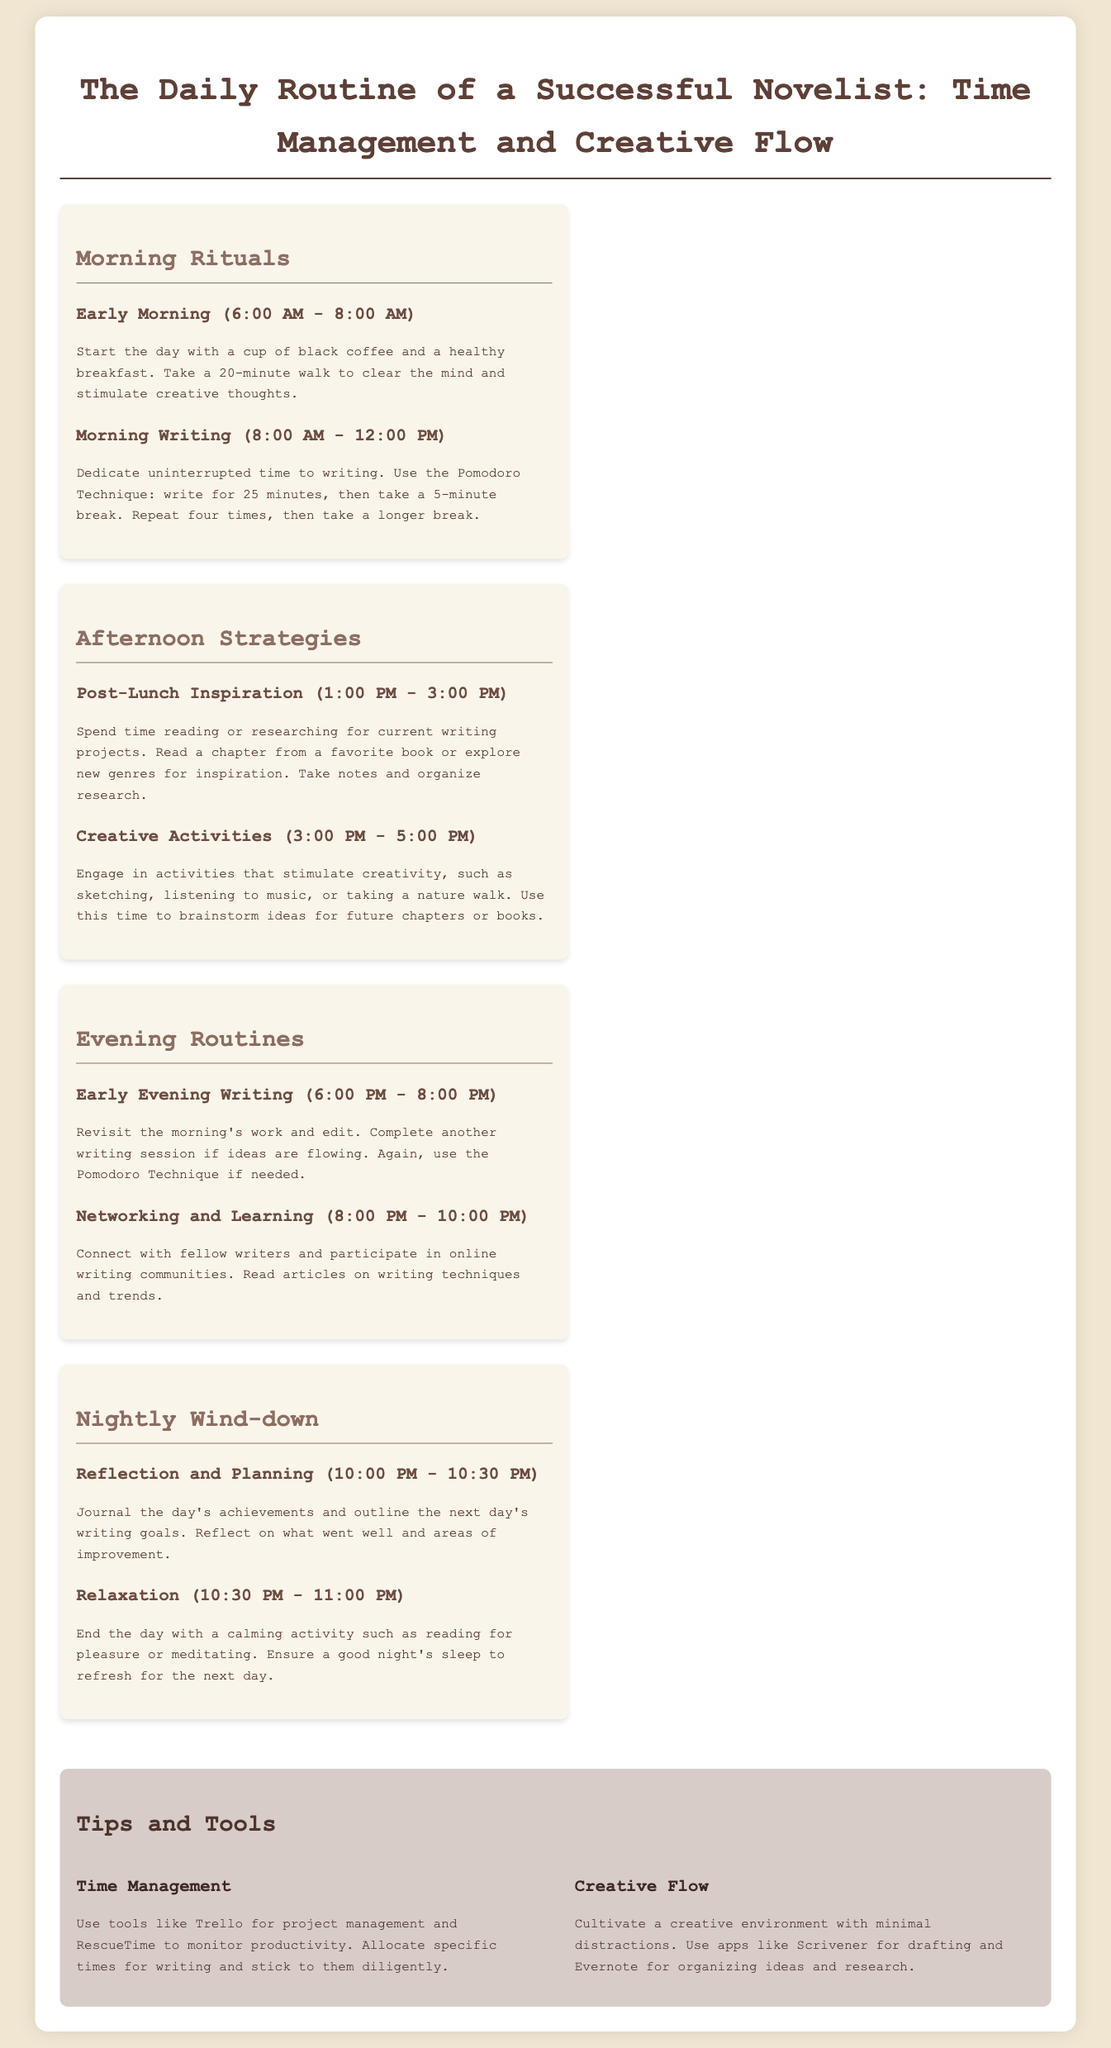What time does the morning writing session start? The document states that the morning writing session starts at 8:00 AM.
Answer: 8:00 AM How long should the post-lunch inspiration last? The document indicates that post-lunch inspiration occurs from 1:00 PM to 3:00 PM, lasting 2 hours.
Answer: 2 hours What technique is suggested for morning writing? The document mentions the Pomodoro Technique for morning writing.
Answer: Pomodoro Technique What is one tool recommended for time management? The document suggests using Trello as a tool for project management.
Answer: Trello How many minutes are spent on each writing session in the Pomodoro Technique? According to the document, each writing session in the Pomodoro Technique lasts for 25 minutes.
Answer: 25 minutes What activity should be done during the nightly wind-down stage? The document specifies that reading for pleasure or meditating can be done during the nightly wind-down.
Answer: Reading for pleasure or meditating What is the end time for the early evening writing session? The early evening writing session ends at 8:00 PM as stated in the document.
Answer: 8:00 PM What is the main focus during the early morning hours? The document indicates that the main focus during early morning hours is on having breakfast and taking a walk.
Answer: Breakfast and taking a walk 